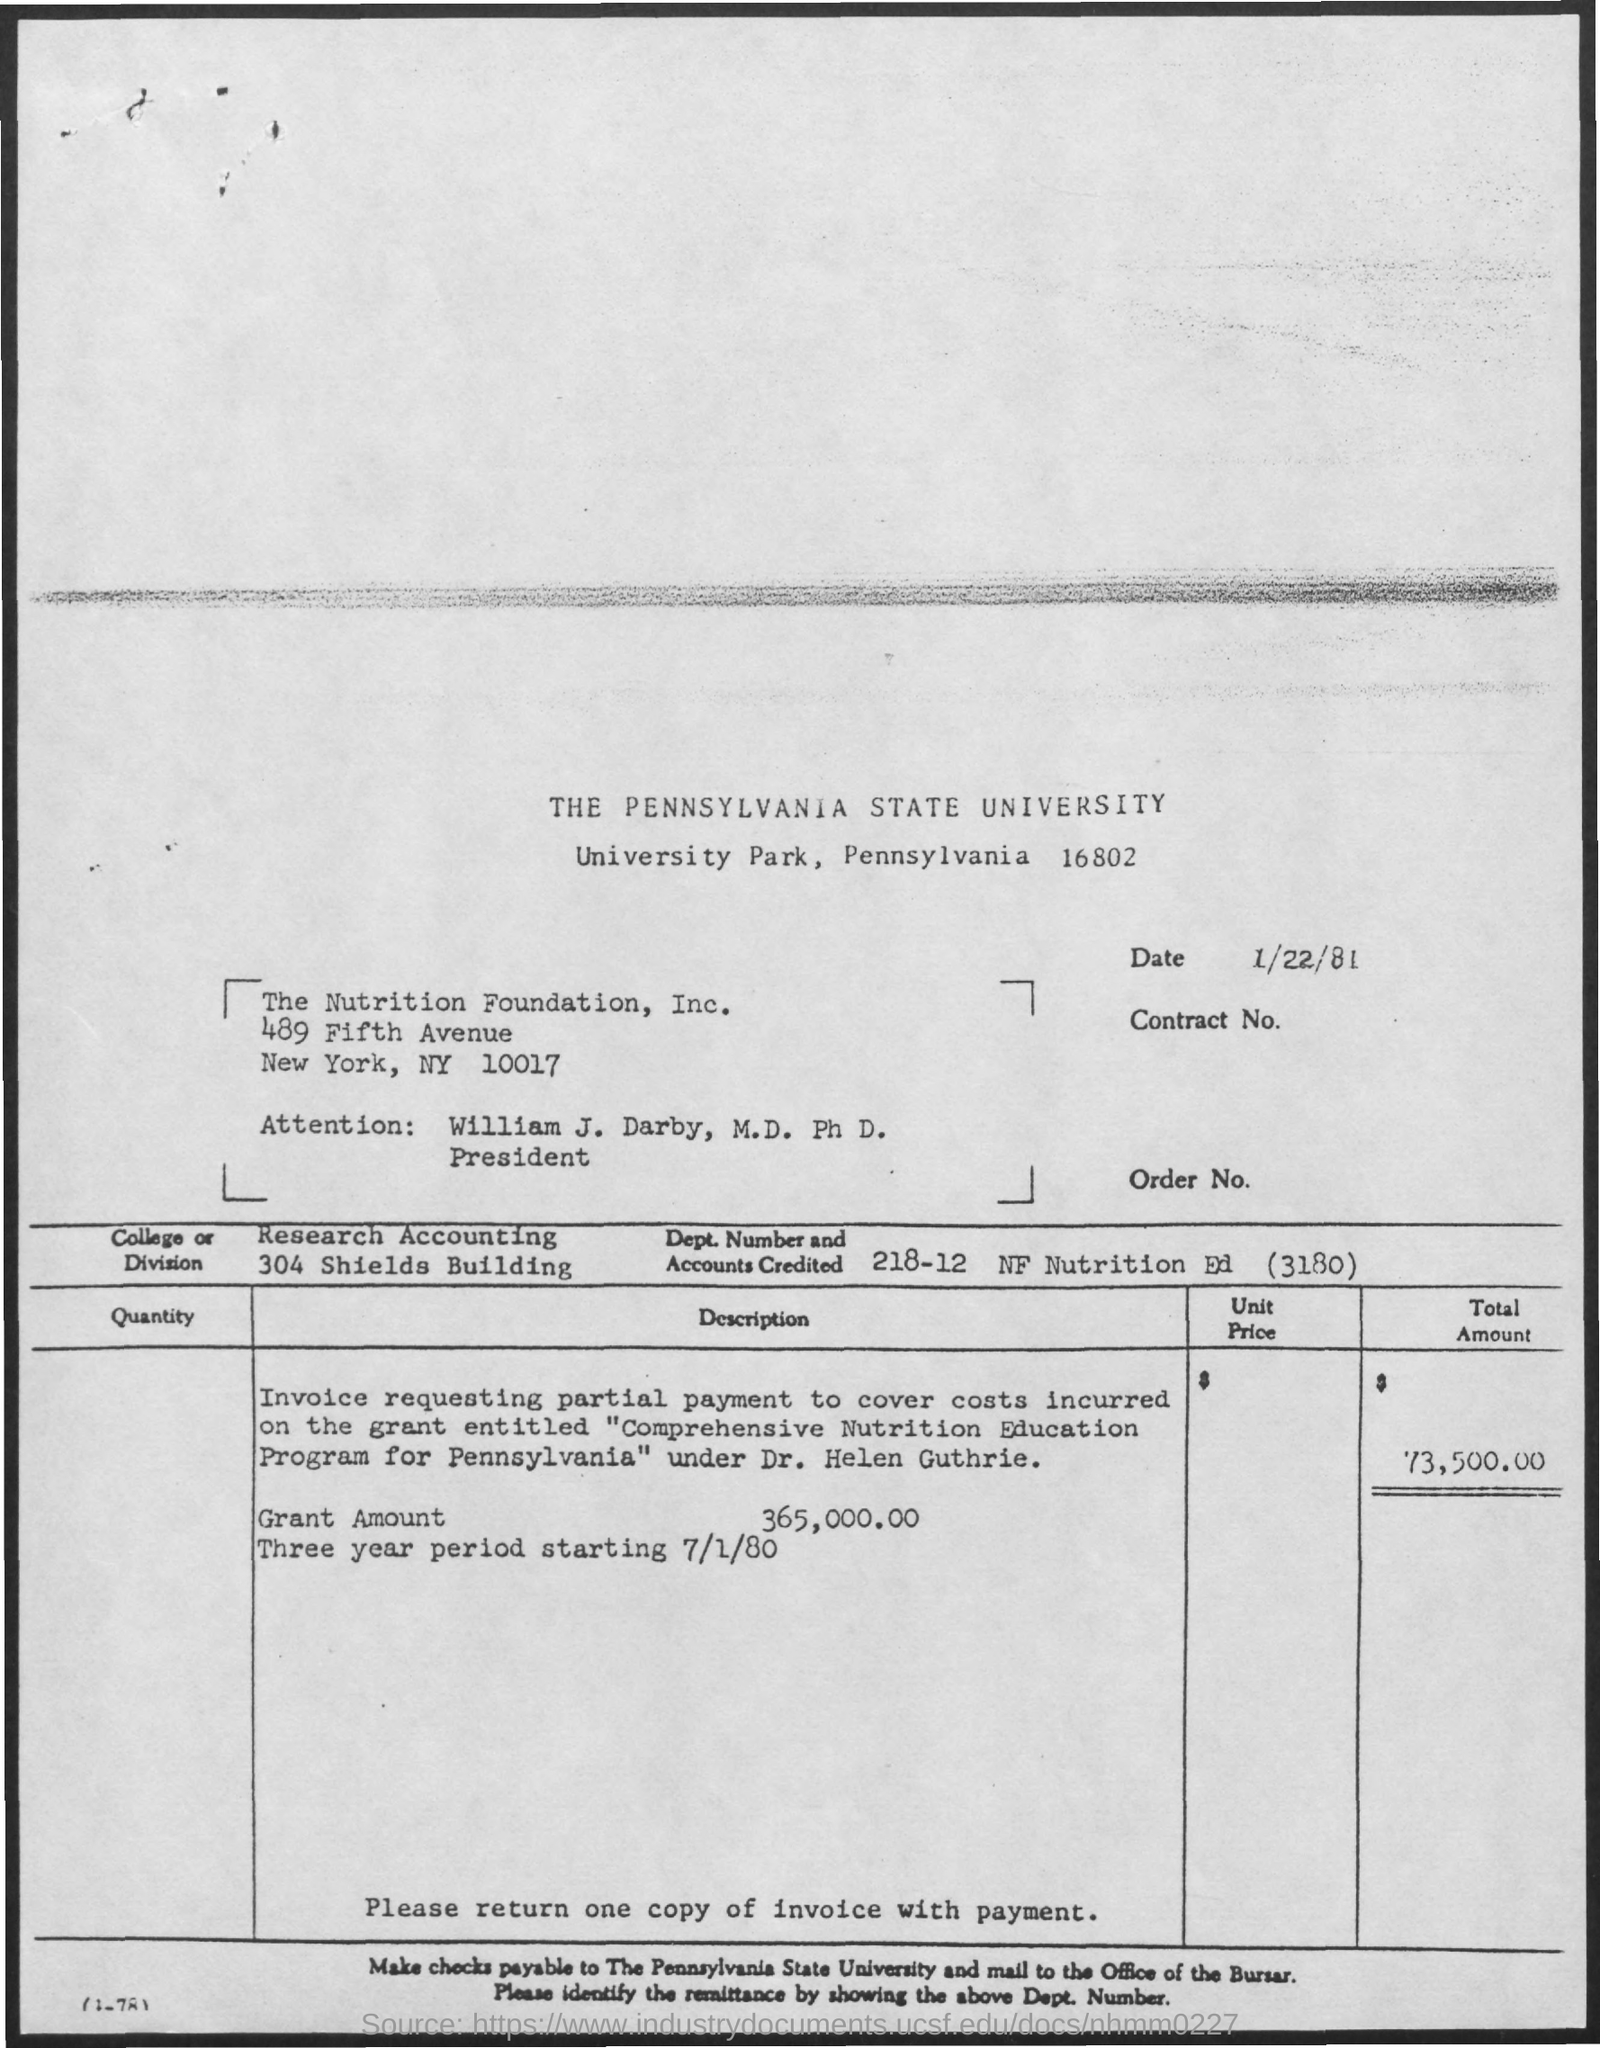What is the total amount?
Provide a short and direct response. 73,500.00. What is the Grant amount?
Offer a terse response. 365,000.00. What is the title of the document?
Keep it short and to the point. The Pennsylvania State University. What is the date above the contract number?
Make the answer very short. 1/22/81. 